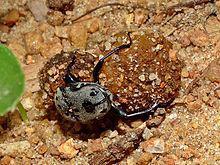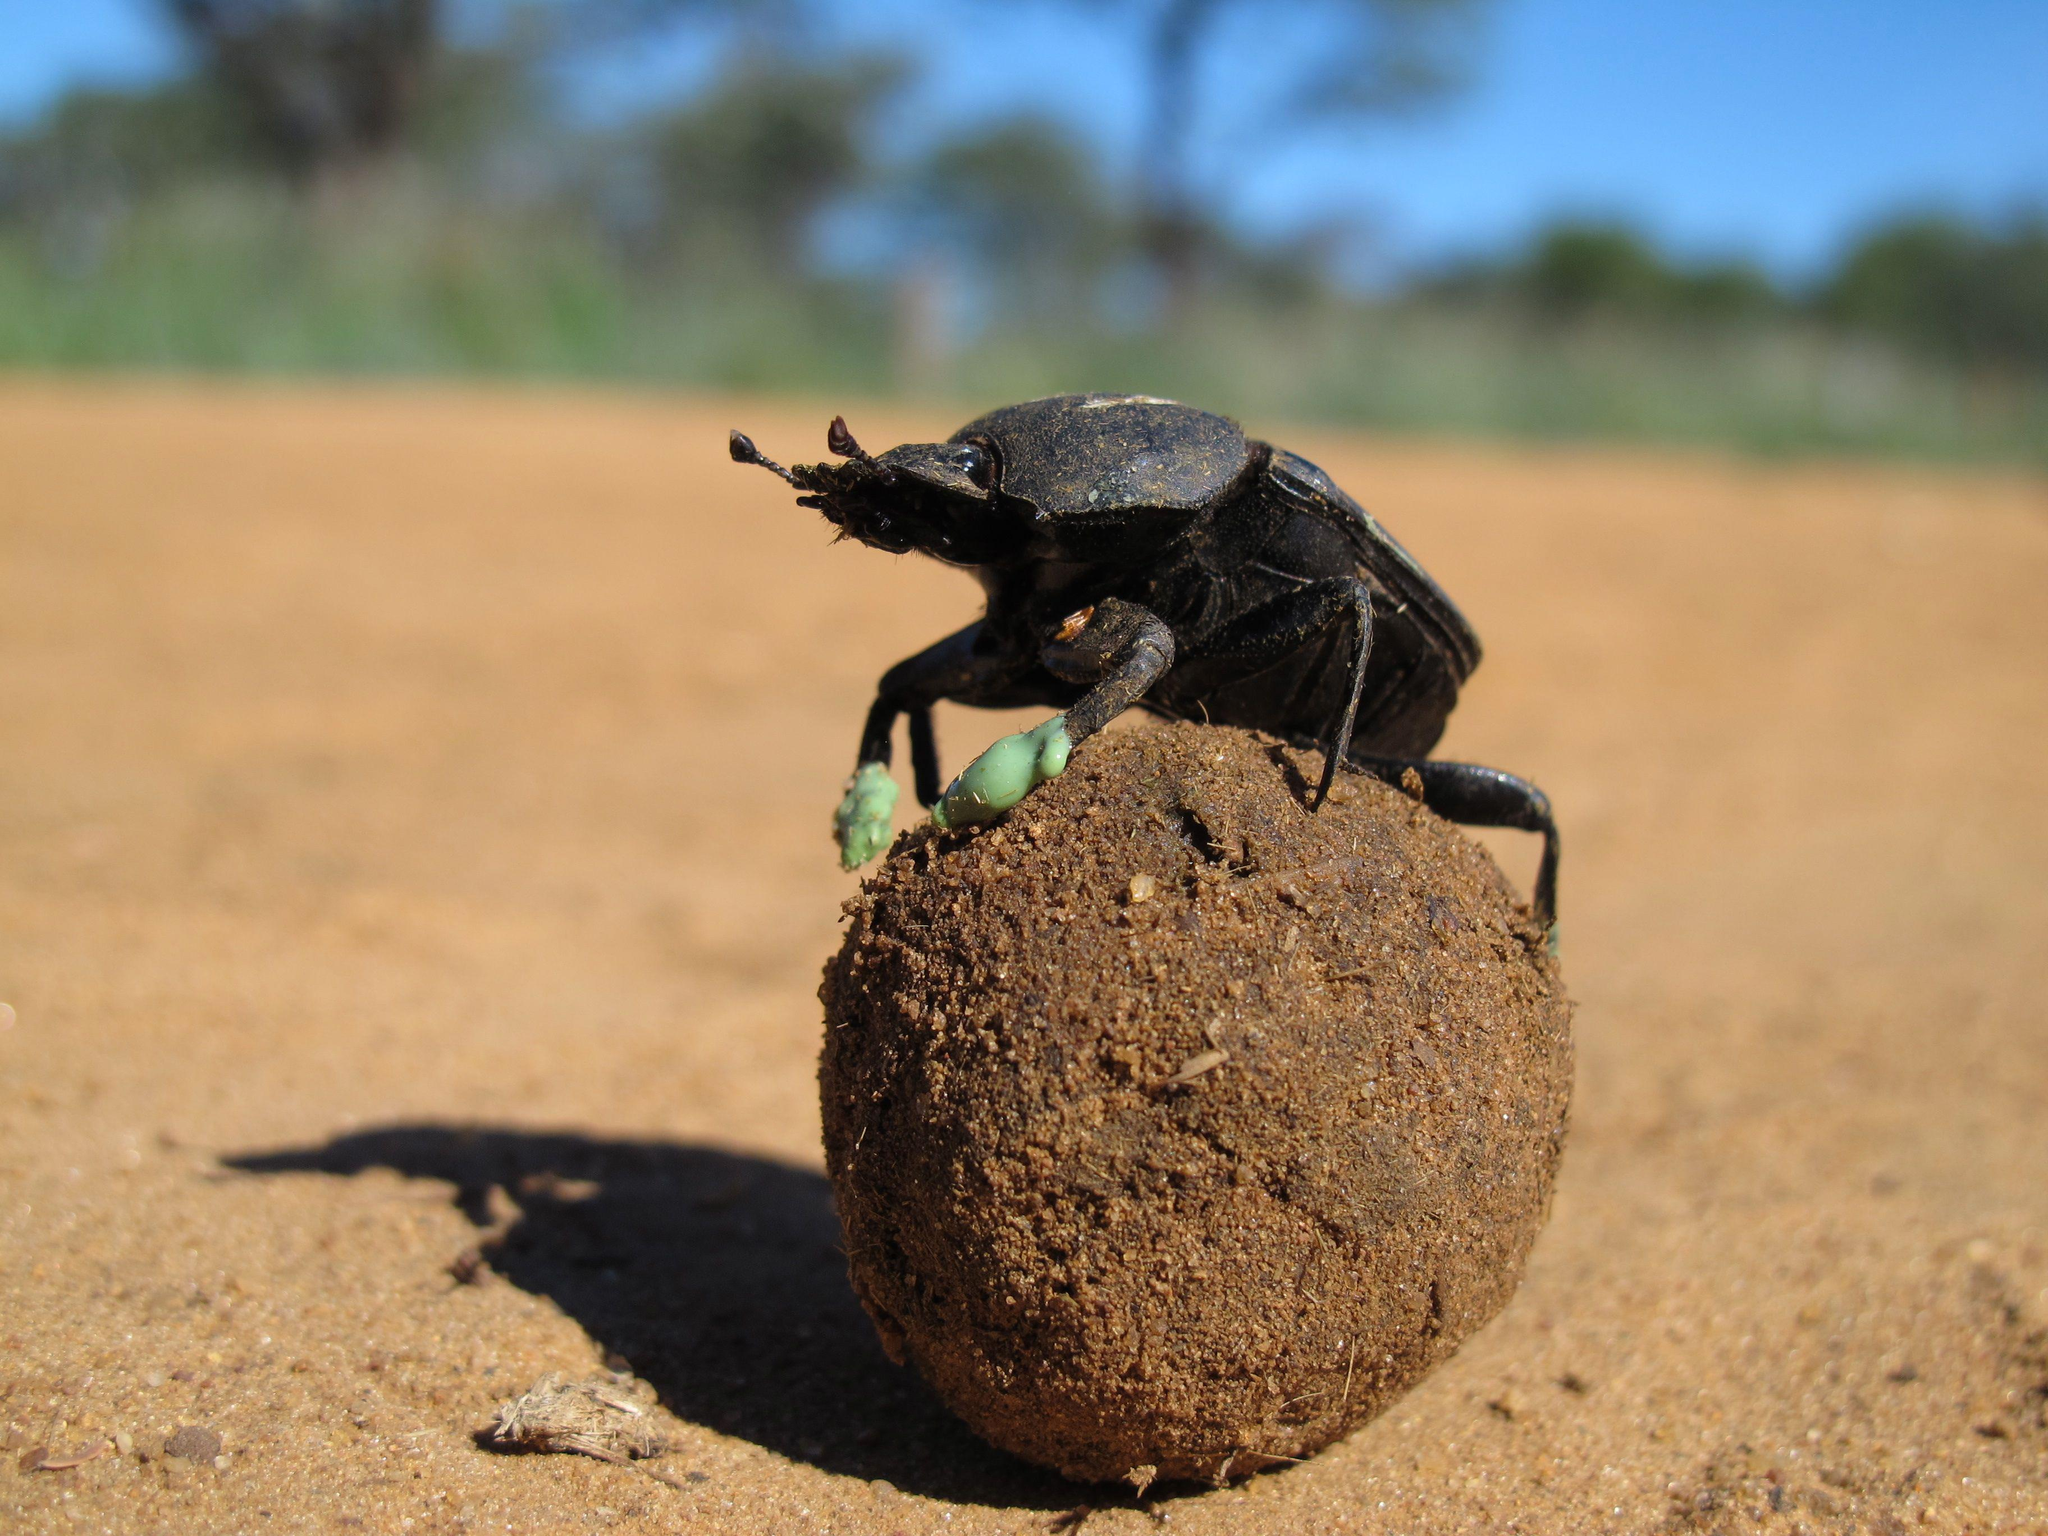The first image is the image on the left, the second image is the image on the right. Considering the images on both sides, is "There are two beatles in total." valid? Answer yes or no. Yes. 